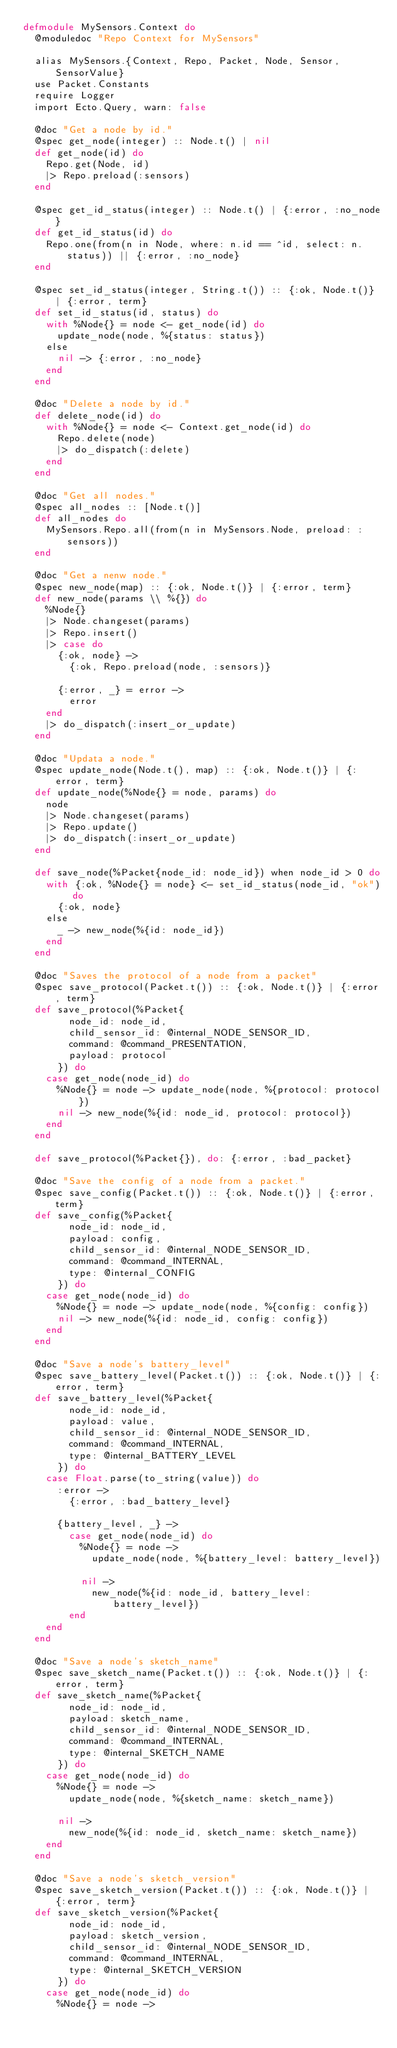Convert code to text. <code><loc_0><loc_0><loc_500><loc_500><_Elixir_>defmodule MySensors.Context do
  @moduledoc "Repo Context for MySensors"

  alias MySensors.{Context, Repo, Packet, Node, Sensor, SensorValue}
  use Packet.Constants
  require Logger
  import Ecto.Query, warn: false

  @doc "Get a node by id."
  @spec get_node(integer) :: Node.t() | nil
  def get_node(id) do
    Repo.get(Node, id)
    |> Repo.preload(:sensors)
  end

  @spec get_id_status(integer) :: Node.t() | {:error, :no_node}
  def get_id_status(id) do
    Repo.one(from(n in Node, where: n.id == ^id, select: n.status)) || {:error, :no_node}
  end

  @spec set_id_status(integer, String.t()) :: {:ok, Node.t()} | {:error, term}
  def set_id_status(id, status) do
    with %Node{} = node <- get_node(id) do
      update_node(node, %{status: status})
    else
      nil -> {:error, :no_node}
    end
  end

  @doc "Delete a node by id."
  def delete_node(id) do
    with %Node{} = node <- Context.get_node(id) do
      Repo.delete(node)
      |> do_dispatch(:delete)
    end
  end

  @doc "Get all nodes."
  @spec all_nodes :: [Node.t()]
  def all_nodes do
    MySensors.Repo.all(from(n in MySensors.Node, preload: :sensors))
  end

  @doc "Get a nenw node."
  @spec new_node(map) :: {:ok, Node.t()} | {:error, term}
  def new_node(params \\ %{}) do
    %Node{}
    |> Node.changeset(params)
    |> Repo.insert()
    |> case do
      {:ok, node} ->
        {:ok, Repo.preload(node, :sensors)}

      {:error, _} = error ->
        error
    end
    |> do_dispatch(:insert_or_update)
  end

  @doc "Updata a node."
  @spec update_node(Node.t(), map) :: {:ok, Node.t()} | {:error, term}
  def update_node(%Node{} = node, params) do
    node
    |> Node.changeset(params)
    |> Repo.update()
    |> do_dispatch(:insert_or_update)
  end

  def save_node(%Packet{node_id: node_id}) when node_id > 0 do
    with {:ok, %Node{} = node} <- set_id_status(node_id, "ok") do
      {:ok, node}
    else
      _ -> new_node(%{id: node_id})
    end
  end

  @doc "Saves the protocol of a node from a packet"
  @spec save_protocol(Packet.t()) :: {:ok, Node.t()} | {:error, term}
  def save_protocol(%Packet{
        node_id: node_id,
        child_sensor_id: @internal_NODE_SENSOR_ID,
        command: @command_PRESENTATION,
        payload: protocol
      }) do
    case get_node(node_id) do
      %Node{} = node -> update_node(node, %{protocol: protocol})
      nil -> new_node(%{id: node_id, protocol: protocol})
    end
  end

  def save_protocol(%Packet{}), do: {:error, :bad_packet}

  @doc "Save the config of a node from a packet."
  @spec save_config(Packet.t()) :: {:ok, Node.t()} | {:error, term}
  def save_config(%Packet{
        node_id: node_id,
        payload: config,
        child_sensor_id: @internal_NODE_SENSOR_ID,
        command: @command_INTERNAL,
        type: @internal_CONFIG
      }) do
    case get_node(node_id) do
      %Node{} = node -> update_node(node, %{config: config})
      nil -> new_node(%{id: node_id, config: config})
    end
  end

  @doc "Save a node's battery_level"
  @spec save_battery_level(Packet.t()) :: {:ok, Node.t()} | {:error, term}
  def save_battery_level(%Packet{
        node_id: node_id,
        payload: value,
        child_sensor_id: @internal_NODE_SENSOR_ID,
        command: @command_INTERNAL,
        type: @internal_BATTERY_LEVEL
      }) do
    case Float.parse(to_string(value)) do
      :error ->
        {:error, :bad_battery_level}

      {battery_level, _} ->
        case get_node(node_id) do
          %Node{} = node ->
            update_node(node, %{battery_level: battery_level})

          nil ->
            new_node(%{id: node_id, battery_level: battery_level})
        end
    end
  end

  @doc "Save a node's sketch_name"
  @spec save_sketch_name(Packet.t()) :: {:ok, Node.t()} | {:error, term}
  def save_sketch_name(%Packet{
        node_id: node_id,
        payload: sketch_name,
        child_sensor_id: @internal_NODE_SENSOR_ID,
        command: @command_INTERNAL,
        type: @internal_SKETCH_NAME
      }) do
    case get_node(node_id) do
      %Node{} = node ->
        update_node(node, %{sketch_name: sketch_name})

      nil ->
        new_node(%{id: node_id, sketch_name: sketch_name})
    end
  end

  @doc "Save a node's sketch_version"
  @spec save_sketch_version(Packet.t()) :: {:ok, Node.t()} | {:error, term}
  def save_sketch_version(%Packet{
        node_id: node_id,
        payload: sketch_version,
        child_sensor_id: @internal_NODE_SENSOR_ID,
        command: @command_INTERNAL,
        type: @internal_SKETCH_VERSION
      }) do
    case get_node(node_id) do
      %Node{} = node -></code> 